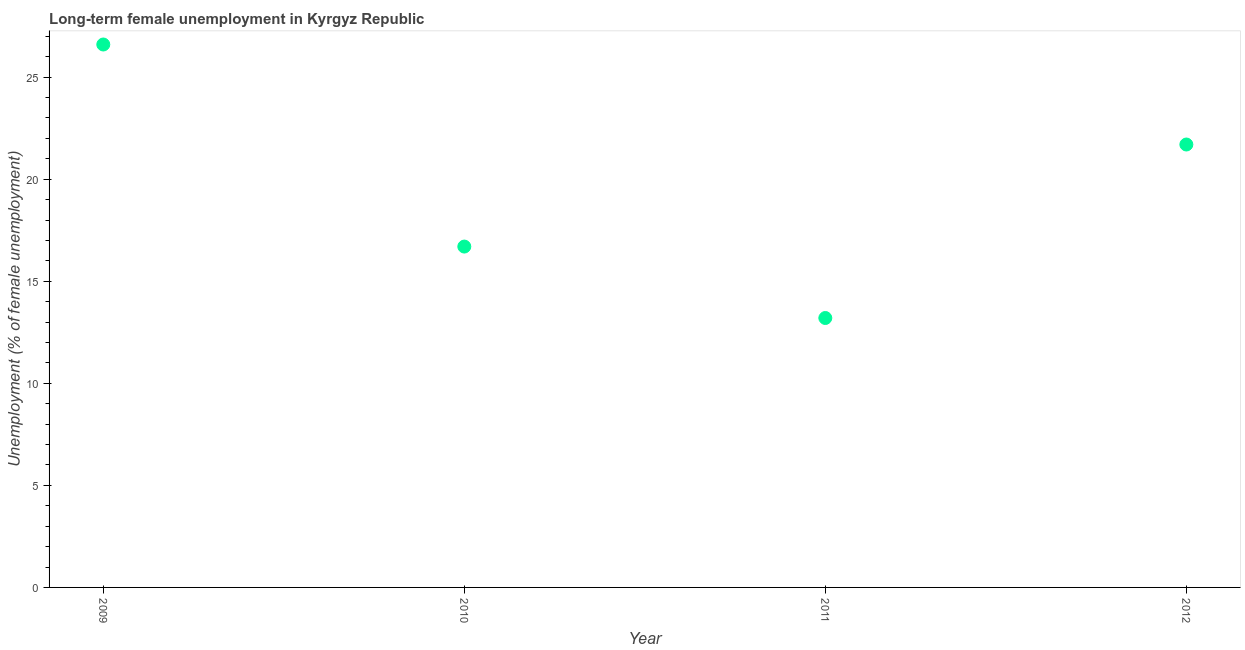What is the long-term female unemployment in 2010?
Ensure brevity in your answer.  16.7. Across all years, what is the maximum long-term female unemployment?
Ensure brevity in your answer.  26.6. Across all years, what is the minimum long-term female unemployment?
Your answer should be compact. 13.2. In which year was the long-term female unemployment minimum?
Your answer should be compact. 2011. What is the sum of the long-term female unemployment?
Keep it short and to the point. 78.2. What is the difference between the long-term female unemployment in 2009 and 2010?
Keep it short and to the point. 9.9. What is the average long-term female unemployment per year?
Your response must be concise. 19.55. What is the median long-term female unemployment?
Keep it short and to the point. 19.2. Do a majority of the years between 2010 and 2012 (inclusive) have long-term female unemployment greater than 19 %?
Provide a short and direct response. No. What is the ratio of the long-term female unemployment in 2009 to that in 2011?
Keep it short and to the point. 2.02. Is the difference between the long-term female unemployment in 2009 and 2012 greater than the difference between any two years?
Provide a short and direct response. No. What is the difference between the highest and the second highest long-term female unemployment?
Offer a very short reply. 4.9. Is the sum of the long-term female unemployment in 2010 and 2012 greater than the maximum long-term female unemployment across all years?
Provide a short and direct response. Yes. What is the difference between the highest and the lowest long-term female unemployment?
Your answer should be compact. 13.4. In how many years, is the long-term female unemployment greater than the average long-term female unemployment taken over all years?
Make the answer very short. 2. How many dotlines are there?
Provide a succinct answer. 1. How many years are there in the graph?
Your answer should be compact. 4. Does the graph contain grids?
Provide a short and direct response. No. What is the title of the graph?
Your answer should be very brief. Long-term female unemployment in Kyrgyz Republic. What is the label or title of the X-axis?
Your answer should be compact. Year. What is the label or title of the Y-axis?
Keep it short and to the point. Unemployment (% of female unemployment). What is the Unemployment (% of female unemployment) in 2009?
Your response must be concise. 26.6. What is the Unemployment (% of female unemployment) in 2010?
Give a very brief answer. 16.7. What is the Unemployment (% of female unemployment) in 2011?
Your response must be concise. 13.2. What is the Unemployment (% of female unemployment) in 2012?
Ensure brevity in your answer.  21.7. What is the difference between the Unemployment (% of female unemployment) in 2009 and 2010?
Provide a succinct answer. 9.9. What is the difference between the Unemployment (% of female unemployment) in 2010 and 2012?
Make the answer very short. -5. What is the ratio of the Unemployment (% of female unemployment) in 2009 to that in 2010?
Your answer should be very brief. 1.59. What is the ratio of the Unemployment (% of female unemployment) in 2009 to that in 2011?
Make the answer very short. 2.02. What is the ratio of the Unemployment (% of female unemployment) in 2009 to that in 2012?
Keep it short and to the point. 1.23. What is the ratio of the Unemployment (% of female unemployment) in 2010 to that in 2011?
Ensure brevity in your answer.  1.26. What is the ratio of the Unemployment (% of female unemployment) in 2010 to that in 2012?
Give a very brief answer. 0.77. What is the ratio of the Unemployment (% of female unemployment) in 2011 to that in 2012?
Your response must be concise. 0.61. 